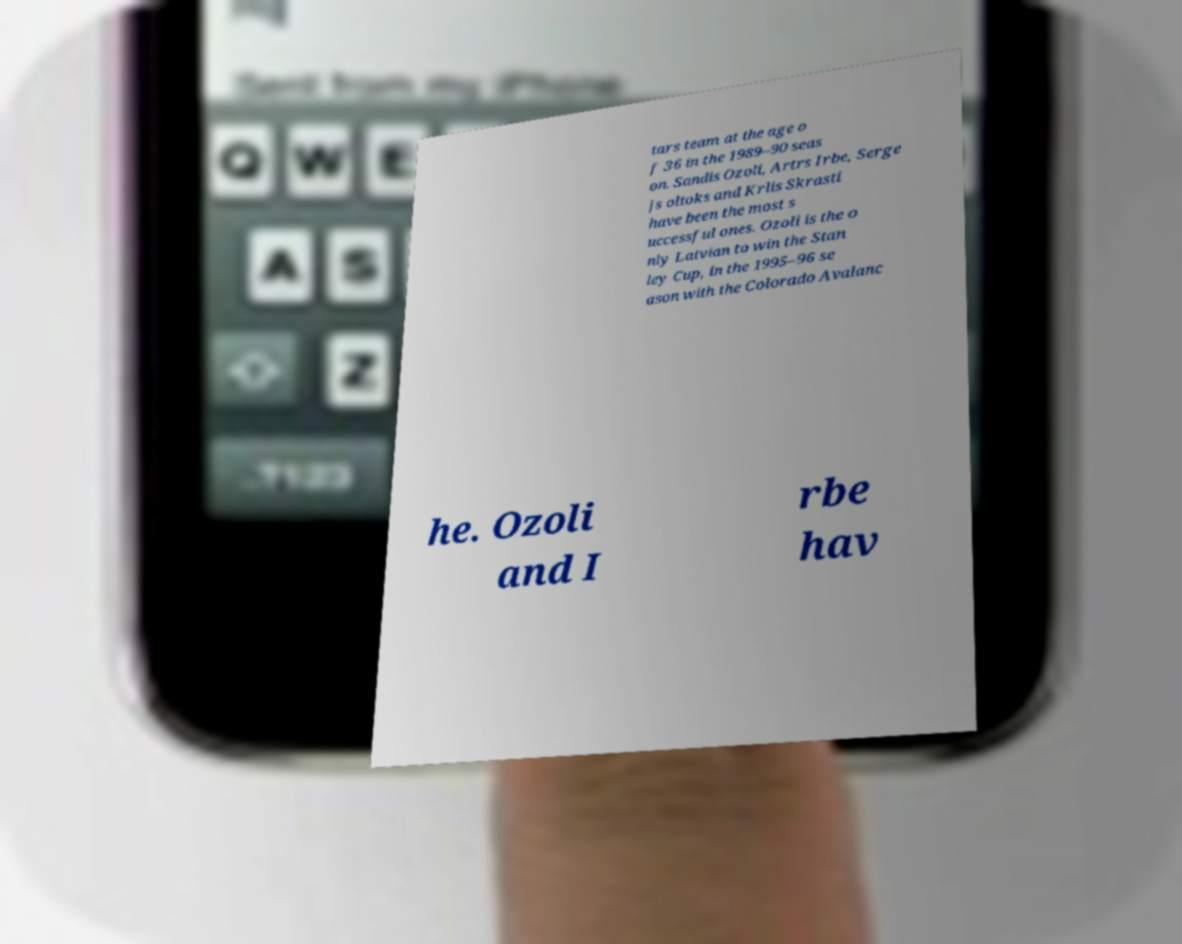For documentation purposes, I need the text within this image transcribed. Could you provide that? tars team at the age o f 36 in the 1989–90 seas on. Sandis Ozoli, Artrs Irbe, Serge js oltoks and Krlis Skrasti have been the most s uccessful ones. Ozoli is the o nly Latvian to win the Stan ley Cup, in the 1995–96 se ason with the Colorado Avalanc he. Ozoli and I rbe hav 